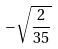<formula> <loc_0><loc_0><loc_500><loc_500>- \sqrt { \frac { 2 } { 3 5 } }</formula> 